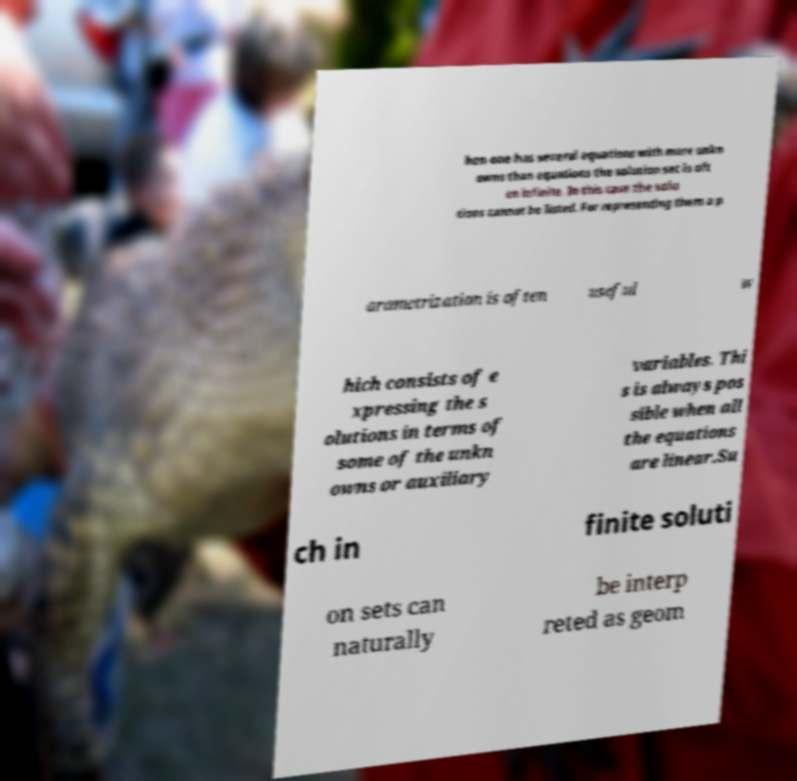Can you accurately transcribe the text from the provided image for me? hen one has several equations with more unkn owns than equations the solution set is oft en infinite. In this case the solu tions cannot be listed. For representing them a p arametrization is often useful w hich consists of e xpressing the s olutions in terms of some of the unkn owns or auxiliary variables. Thi s is always pos sible when all the equations are linear.Su ch in finite soluti on sets can naturally be interp reted as geom 